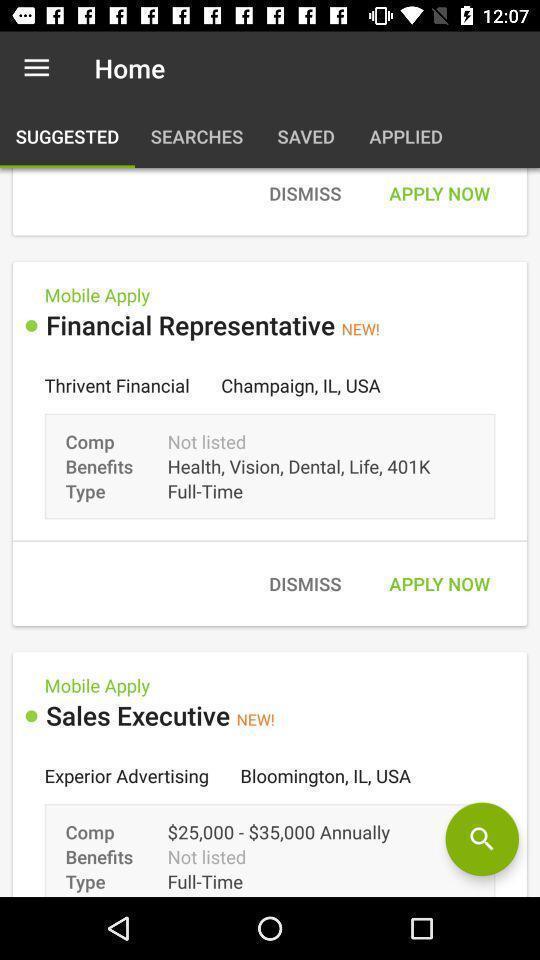Provide a textual representation of this image. Screen shows home page options in a job app. 